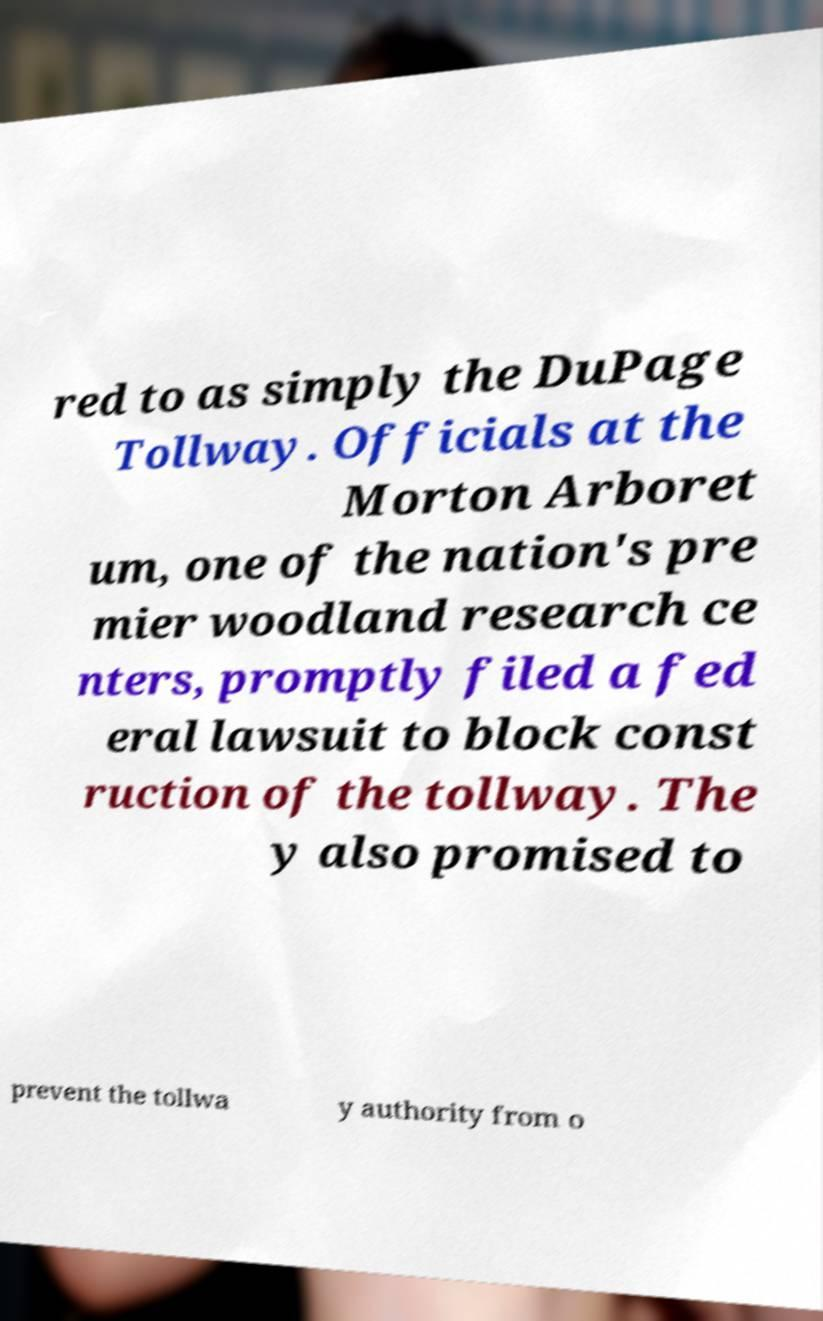For documentation purposes, I need the text within this image transcribed. Could you provide that? red to as simply the DuPage Tollway. Officials at the Morton Arboret um, one of the nation's pre mier woodland research ce nters, promptly filed a fed eral lawsuit to block const ruction of the tollway. The y also promised to prevent the tollwa y authority from o 